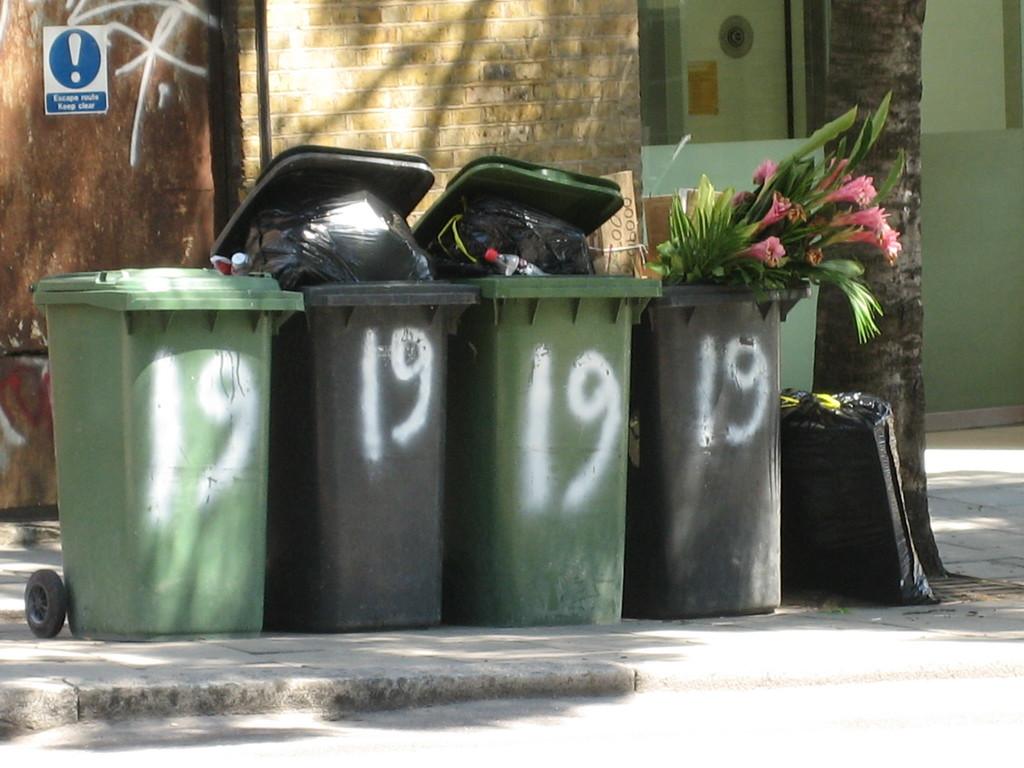What is the number on these bins?
Your answer should be very brief. 19. 